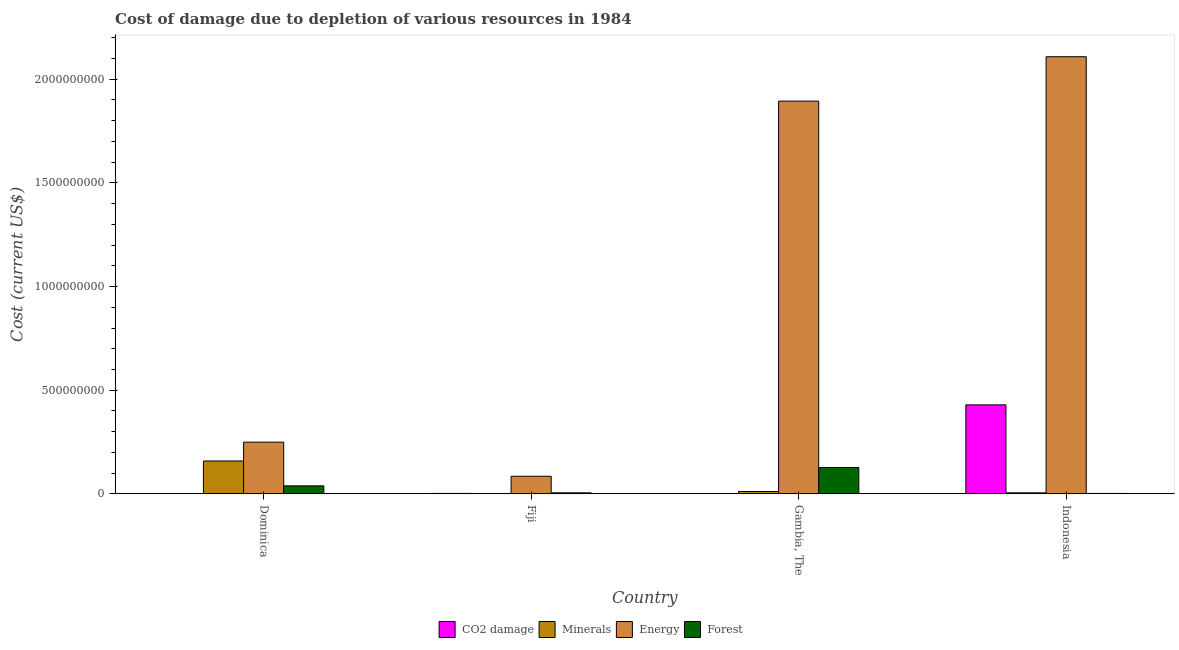How many groups of bars are there?
Your answer should be compact. 4. Are the number of bars per tick equal to the number of legend labels?
Provide a short and direct response. Yes. Are the number of bars on each tick of the X-axis equal?
Provide a short and direct response. Yes. How many bars are there on the 1st tick from the right?
Offer a terse response. 4. What is the cost of damage due to depletion of minerals in Fiji?
Your answer should be very brief. 1.35e+06. Across all countries, what is the maximum cost of damage due to depletion of coal?
Your answer should be very brief. 4.29e+08. Across all countries, what is the minimum cost of damage due to depletion of coal?
Ensure brevity in your answer.  1.68e+05. In which country was the cost of damage due to depletion of forests maximum?
Ensure brevity in your answer.  Gambia, The. In which country was the cost of damage due to depletion of coal minimum?
Offer a very short reply. Dominica. What is the total cost of damage due to depletion of minerals in the graph?
Offer a terse response. 1.76e+08. What is the difference between the cost of damage due to depletion of forests in Dominica and that in Indonesia?
Make the answer very short. 3.66e+07. What is the difference between the cost of damage due to depletion of forests in Fiji and the cost of damage due to depletion of energy in Indonesia?
Your response must be concise. -2.10e+09. What is the average cost of damage due to depletion of coal per country?
Give a very brief answer. 1.08e+08. What is the difference between the cost of damage due to depletion of forests and cost of damage due to depletion of energy in Gambia, The?
Your answer should be very brief. -1.77e+09. In how many countries, is the cost of damage due to depletion of minerals greater than 200000000 US$?
Keep it short and to the point. 0. What is the ratio of the cost of damage due to depletion of energy in Dominica to that in Fiji?
Ensure brevity in your answer.  2.94. What is the difference between the highest and the second highest cost of damage due to depletion of energy?
Your response must be concise. 2.14e+08. What is the difference between the highest and the lowest cost of damage due to depletion of minerals?
Ensure brevity in your answer.  1.57e+08. What does the 2nd bar from the left in Indonesia represents?
Your answer should be compact. Minerals. What does the 4th bar from the right in Fiji represents?
Keep it short and to the point. CO2 damage. How many bars are there?
Keep it short and to the point. 16. Are all the bars in the graph horizontal?
Offer a very short reply. No. Does the graph contain any zero values?
Offer a very short reply. No. Where does the legend appear in the graph?
Offer a terse response. Bottom center. How are the legend labels stacked?
Offer a very short reply. Horizontal. What is the title of the graph?
Your response must be concise. Cost of damage due to depletion of various resources in 1984 . Does "Taxes on exports" appear as one of the legend labels in the graph?
Give a very brief answer. No. What is the label or title of the X-axis?
Offer a very short reply. Country. What is the label or title of the Y-axis?
Ensure brevity in your answer.  Cost (current US$). What is the Cost (current US$) of CO2 damage in Dominica?
Keep it short and to the point. 1.68e+05. What is the Cost (current US$) in Minerals in Dominica?
Ensure brevity in your answer.  1.59e+08. What is the Cost (current US$) in Energy in Dominica?
Keep it short and to the point. 2.49e+08. What is the Cost (current US$) of Forest in Dominica?
Make the answer very short. 3.86e+07. What is the Cost (current US$) of CO2 damage in Fiji?
Provide a succinct answer. 2.23e+06. What is the Cost (current US$) of Minerals in Fiji?
Offer a very short reply. 1.35e+06. What is the Cost (current US$) of Energy in Fiji?
Your response must be concise. 8.49e+07. What is the Cost (current US$) in Forest in Fiji?
Your answer should be very brief. 4.96e+06. What is the Cost (current US$) of CO2 damage in Gambia, The?
Offer a terse response. 6.60e+05. What is the Cost (current US$) in Minerals in Gambia, The?
Ensure brevity in your answer.  1.14e+07. What is the Cost (current US$) in Energy in Gambia, The?
Offer a very short reply. 1.89e+09. What is the Cost (current US$) in Forest in Gambia, The?
Offer a very short reply. 1.27e+08. What is the Cost (current US$) of CO2 damage in Indonesia?
Your answer should be very brief. 4.29e+08. What is the Cost (current US$) of Minerals in Indonesia?
Offer a very short reply. 4.91e+06. What is the Cost (current US$) in Energy in Indonesia?
Provide a short and direct response. 2.11e+09. What is the Cost (current US$) of Forest in Indonesia?
Give a very brief answer. 2.04e+06. Across all countries, what is the maximum Cost (current US$) of CO2 damage?
Your response must be concise. 4.29e+08. Across all countries, what is the maximum Cost (current US$) in Minerals?
Make the answer very short. 1.59e+08. Across all countries, what is the maximum Cost (current US$) of Energy?
Your answer should be very brief. 2.11e+09. Across all countries, what is the maximum Cost (current US$) of Forest?
Ensure brevity in your answer.  1.27e+08. Across all countries, what is the minimum Cost (current US$) of CO2 damage?
Your response must be concise. 1.68e+05. Across all countries, what is the minimum Cost (current US$) of Minerals?
Provide a short and direct response. 1.35e+06. Across all countries, what is the minimum Cost (current US$) of Energy?
Offer a very short reply. 8.49e+07. Across all countries, what is the minimum Cost (current US$) of Forest?
Your answer should be compact. 2.04e+06. What is the total Cost (current US$) of CO2 damage in the graph?
Your answer should be very brief. 4.32e+08. What is the total Cost (current US$) in Minerals in the graph?
Your answer should be very brief. 1.76e+08. What is the total Cost (current US$) in Energy in the graph?
Make the answer very short. 4.34e+09. What is the total Cost (current US$) of Forest in the graph?
Give a very brief answer. 1.73e+08. What is the difference between the Cost (current US$) of CO2 damage in Dominica and that in Fiji?
Offer a very short reply. -2.06e+06. What is the difference between the Cost (current US$) in Minerals in Dominica and that in Fiji?
Make the answer very short. 1.57e+08. What is the difference between the Cost (current US$) of Energy in Dominica and that in Fiji?
Your response must be concise. 1.64e+08. What is the difference between the Cost (current US$) of Forest in Dominica and that in Fiji?
Give a very brief answer. 3.36e+07. What is the difference between the Cost (current US$) of CO2 damage in Dominica and that in Gambia, The?
Your response must be concise. -4.91e+05. What is the difference between the Cost (current US$) in Minerals in Dominica and that in Gambia, The?
Provide a short and direct response. 1.47e+08. What is the difference between the Cost (current US$) in Energy in Dominica and that in Gambia, The?
Make the answer very short. -1.64e+09. What is the difference between the Cost (current US$) of Forest in Dominica and that in Gambia, The?
Give a very brief answer. -8.85e+07. What is the difference between the Cost (current US$) in CO2 damage in Dominica and that in Indonesia?
Provide a succinct answer. -4.29e+08. What is the difference between the Cost (current US$) of Minerals in Dominica and that in Indonesia?
Your response must be concise. 1.54e+08. What is the difference between the Cost (current US$) in Energy in Dominica and that in Indonesia?
Ensure brevity in your answer.  -1.86e+09. What is the difference between the Cost (current US$) in Forest in Dominica and that in Indonesia?
Offer a very short reply. 3.66e+07. What is the difference between the Cost (current US$) of CO2 damage in Fiji and that in Gambia, The?
Give a very brief answer. 1.57e+06. What is the difference between the Cost (current US$) in Minerals in Fiji and that in Gambia, The?
Keep it short and to the point. -1.00e+07. What is the difference between the Cost (current US$) in Energy in Fiji and that in Gambia, The?
Offer a very short reply. -1.81e+09. What is the difference between the Cost (current US$) of Forest in Fiji and that in Gambia, The?
Offer a terse response. -1.22e+08. What is the difference between the Cost (current US$) in CO2 damage in Fiji and that in Indonesia?
Your response must be concise. -4.27e+08. What is the difference between the Cost (current US$) of Minerals in Fiji and that in Indonesia?
Your answer should be compact. -3.56e+06. What is the difference between the Cost (current US$) of Energy in Fiji and that in Indonesia?
Your answer should be compact. -2.02e+09. What is the difference between the Cost (current US$) of Forest in Fiji and that in Indonesia?
Offer a very short reply. 2.92e+06. What is the difference between the Cost (current US$) in CO2 damage in Gambia, The and that in Indonesia?
Ensure brevity in your answer.  -4.29e+08. What is the difference between the Cost (current US$) in Minerals in Gambia, The and that in Indonesia?
Ensure brevity in your answer.  6.45e+06. What is the difference between the Cost (current US$) in Energy in Gambia, The and that in Indonesia?
Offer a very short reply. -2.14e+08. What is the difference between the Cost (current US$) of Forest in Gambia, The and that in Indonesia?
Give a very brief answer. 1.25e+08. What is the difference between the Cost (current US$) in CO2 damage in Dominica and the Cost (current US$) in Minerals in Fiji?
Your answer should be very brief. -1.18e+06. What is the difference between the Cost (current US$) in CO2 damage in Dominica and the Cost (current US$) in Energy in Fiji?
Provide a succinct answer. -8.48e+07. What is the difference between the Cost (current US$) in CO2 damage in Dominica and the Cost (current US$) in Forest in Fiji?
Offer a very short reply. -4.79e+06. What is the difference between the Cost (current US$) of Minerals in Dominica and the Cost (current US$) of Energy in Fiji?
Give a very brief answer. 7.37e+07. What is the difference between the Cost (current US$) of Minerals in Dominica and the Cost (current US$) of Forest in Fiji?
Your answer should be compact. 1.54e+08. What is the difference between the Cost (current US$) in Energy in Dominica and the Cost (current US$) in Forest in Fiji?
Offer a very short reply. 2.44e+08. What is the difference between the Cost (current US$) of CO2 damage in Dominica and the Cost (current US$) of Minerals in Gambia, The?
Your answer should be compact. -1.12e+07. What is the difference between the Cost (current US$) of CO2 damage in Dominica and the Cost (current US$) of Energy in Gambia, The?
Give a very brief answer. -1.89e+09. What is the difference between the Cost (current US$) in CO2 damage in Dominica and the Cost (current US$) in Forest in Gambia, The?
Keep it short and to the point. -1.27e+08. What is the difference between the Cost (current US$) of Minerals in Dominica and the Cost (current US$) of Energy in Gambia, The?
Ensure brevity in your answer.  -1.74e+09. What is the difference between the Cost (current US$) in Minerals in Dominica and the Cost (current US$) in Forest in Gambia, The?
Provide a succinct answer. 3.15e+07. What is the difference between the Cost (current US$) in Energy in Dominica and the Cost (current US$) in Forest in Gambia, The?
Provide a short and direct response. 1.22e+08. What is the difference between the Cost (current US$) in CO2 damage in Dominica and the Cost (current US$) in Minerals in Indonesia?
Ensure brevity in your answer.  -4.74e+06. What is the difference between the Cost (current US$) of CO2 damage in Dominica and the Cost (current US$) of Energy in Indonesia?
Your answer should be compact. -2.11e+09. What is the difference between the Cost (current US$) of CO2 damage in Dominica and the Cost (current US$) of Forest in Indonesia?
Your answer should be very brief. -1.87e+06. What is the difference between the Cost (current US$) of Minerals in Dominica and the Cost (current US$) of Energy in Indonesia?
Your answer should be very brief. -1.95e+09. What is the difference between the Cost (current US$) of Minerals in Dominica and the Cost (current US$) of Forest in Indonesia?
Give a very brief answer. 1.57e+08. What is the difference between the Cost (current US$) of Energy in Dominica and the Cost (current US$) of Forest in Indonesia?
Your response must be concise. 2.47e+08. What is the difference between the Cost (current US$) in CO2 damage in Fiji and the Cost (current US$) in Minerals in Gambia, The?
Give a very brief answer. -9.14e+06. What is the difference between the Cost (current US$) in CO2 damage in Fiji and the Cost (current US$) in Energy in Gambia, The?
Your answer should be compact. -1.89e+09. What is the difference between the Cost (current US$) in CO2 damage in Fiji and the Cost (current US$) in Forest in Gambia, The?
Provide a short and direct response. -1.25e+08. What is the difference between the Cost (current US$) in Minerals in Fiji and the Cost (current US$) in Energy in Gambia, The?
Keep it short and to the point. -1.89e+09. What is the difference between the Cost (current US$) of Minerals in Fiji and the Cost (current US$) of Forest in Gambia, The?
Make the answer very short. -1.26e+08. What is the difference between the Cost (current US$) in Energy in Fiji and the Cost (current US$) in Forest in Gambia, The?
Give a very brief answer. -4.22e+07. What is the difference between the Cost (current US$) in CO2 damage in Fiji and the Cost (current US$) in Minerals in Indonesia?
Your answer should be compact. -2.68e+06. What is the difference between the Cost (current US$) of CO2 damage in Fiji and the Cost (current US$) of Energy in Indonesia?
Your answer should be very brief. -2.11e+09. What is the difference between the Cost (current US$) in CO2 damage in Fiji and the Cost (current US$) in Forest in Indonesia?
Make the answer very short. 1.93e+05. What is the difference between the Cost (current US$) in Minerals in Fiji and the Cost (current US$) in Energy in Indonesia?
Your response must be concise. -2.11e+09. What is the difference between the Cost (current US$) of Minerals in Fiji and the Cost (current US$) of Forest in Indonesia?
Your answer should be very brief. -6.85e+05. What is the difference between the Cost (current US$) in Energy in Fiji and the Cost (current US$) in Forest in Indonesia?
Offer a very short reply. 8.29e+07. What is the difference between the Cost (current US$) in CO2 damage in Gambia, The and the Cost (current US$) in Minerals in Indonesia?
Give a very brief answer. -4.25e+06. What is the difference between the Cost (current US$) in CO2 damage in Gambia, The and the Cost (current US$) in Energy in Indonesia?
Make the answer very short. -2.11e+09. What is the difference between the Cost (current US$) of CO2 damage in Gambia, The and the Cost (current US$) of Forest in Indonesia?
Your answer should be compact. -1.38e+06. What is the difference between the Cost (current US$) in Minerals in Gambia, The and the Cost (current US$) in Energy in Indonesia?
Offer a very short reply. -2.10e+09. What is the difference between the Cost (current US$) of Minerals in Gambia, The and the Cost (current US$) of Forest in Indonesia?
Provide a succinct answer. 9.33e+06. What is the difference between the Cost (current US$) in Energy in Gambia, The and the Cost (current US$) in Forest in Indonesia?
Your answer should be very brief. 1.89e+09. What is the average Cost (current US$) of CO2 damage per country?
Offer a very short reply. 1.08e+08. What is the average Cost (current US$) in Minerals per country?
Provide a succinct answer. 4.41e+07. What is the average Cost (current US$) in Energy per country?
Give a very brief answer. 1.08e+09. What is the average Cost (current US$) of Forest per country?
Provide a succinct answer. 4.32e+07. What is the difference between the Cost (current US$) in CO2 damage and Cost (current US$) in Minerals in Dominica?
Provide a succinct answer. -1.58e+08. What is the difference between the Cost (current US$) in CO2 damage and Cost (current US$) in Energy in Dominica?
Offer a very short reply. -2.49e+08. What is the difference between the Cost (current US$) in CO2 damage and Cost (current US$) in Forest in Dominica?
Your answer should be very brief. -3.84e+07. What is the difference between the Cost (current US$) in Minerals and Cost (current US$) in Energy in Dominica?
Offer a very short reply. -9.08e+07. What is the difference between the Cost (current US$) of Minerals and Cost (current US$) of Forest in Dominica?
Offer a very short reply. 1.20e+08. What is the difference between the Cost (current US$) of Energy and Cost (current US$) of Forest in Dominica?
Make the answer very short. 2.11e+08. What is the difference between the Cost (current US$) in CO2 damage and Cost (current US$) in Minerals in Fiji?
Provide a short and direct response. 8.78e+05. What is the difference between the Cost (current US$) in CO2 damage and Cost (current US$) in Energy in Fiji?
Your answer should be very brief. -8.27e+07. What is the difference between the Cost (current US$) in CO2 damage and Cost (current US$) in Forest in Fiji?
Your answer should be compact. -2.72e+06. What is the difference between the Cost (current US$) in Minerals and Cost (current US$) in Energy in Fiji?
Offer a terse response. -8.36e+07. What is the difference between the Cost (current US$) in Minerals and Cost (current US$) in Forest in Fiji?
Offer a terse response. -3.60e+06. What is the difference between the Cost (current US$) of Energy and Cost (current US$) of Forest in Fiji?
Keep it short and to the point. 8.00e+07. What is the difference between the Cost (current US$) of CO2 damage and Cost (current US$) of Minerals in Gambia, The?
Ensure brevity in your answer.  -1.07e+07. What is the difference between the Cost (current US$) in CO2 damage and Cost (current US$) in Energy in Gambia, The?
Make the answer very short. -1.89e+09. What is the difference between the Cost (current US$) of CO2 damage and Cost (current US$) of Forest in Gambia, The?
Provide a succinct answer. -1.26e+08. What is the difference between the Cost (current US$) of Minerals and Cost (current US$) of Energy in Gambia, The?
Make the answer very short. -1.88e+09. What is the difference between the Cost (current US$) of Minerals and Cost (current US$) of Forest in Gambia, The?
Your answer should be very brief. -1.16e+08. What is the difference between the Cost (current US$) of Energy and Cost (current US$) of Forest in Gambia, The?
Keep it short and to the point. 1.77e+09. What is the difference between the Cost (current US$) of CO2 damage and Cost (current US$) of Minerals in Indonesia?
Offer a terse response. 4.24e+08. What is the difference between the Cost (current US$) of CO2 damage and Cost (current US$) of Energy in Indonesia?
Provide a succinct answer. -1.68e+09. What is the difference between the Cost (current US$) of CO2 damage and Cost (current US$) of Forest in Indonesia?
Keep it short and to the point. 4.27e+08. What is the difference between the Cost (current US$) in Minerals and Cost (current US$) in Energy in Indonesia?
Your response must be concise. -2.10e+09. What is the difference between the Cost (current US$) of Minerals and Cost (current US$) of Forest in Indonesia?
Offer a very short reply. 2.87e+06. What is the difference between the Cost (current US$) in Energy and Cost (current US$) in Forest in Indonesia?
Your response must be concise. 2.11e+09. What is the ratio of the Cost (current US$) in CO2 damage in Dominica to that in Fiji?
Your answer should be compact. 0.08. What is the ratio of the Cost (current US$) of Minerals in Dominica to that in Fiji?
Your response must be concise. 117.23. What is the ratio of the Cost (current US$) in Energy in Dominica to that in Fiji?
Your answer should be compact. 2.94. What is the ratio of the Cost (current US$) in Forest in Dominica to that in Fiji?
Give a very brief answer. 7.79. What is the ratio of the Cost (current US$) in CO2 damage in Dominica to that in Gambia, The?
Ensure brevity in your answer.  0.26. What is the ratio of the Cost (current US$) in Minerals in Dominica to that in Gambia, The?
Give a very brief answer. 13.96. What is the ratio of the Cost (current US$) in Energy in Dominica to that in Gambia, The?
Make the answer very short. 0.13. What is the ratio of the Cost (current US$) in Forest in Dominica to that in Gambia, The?
Make the answer very short. 0.3. What is the ratio of the Cost (current US$) of CO2 damage in Dominica to that in Indonesia?
Offer a very short reply. 0. What is the ratio of the Cost (current US$) in Minerals in Dominica to that in Indonesia?
Offer a terse response. 32.29. What is the ratio of the Cost (current US$) in Energy in Dominica to that in Indonesia?
Provide a succinct answer. 0.12. What is the ratio of the Cost (current US$) in Forest in Dominica to that in Indonesia?
Give a very brief answer. 18.94. What is the ratio of the Cost (current US$) of CO2 damage in Fiji to that in Gambia, The?
Offer a very short reply. 3.38. What is the ratio of the Cost (current US$) of Minerals in Fiji to that in Gambia, The?
Your response must be concise. 0.12. What is the ratio of the Cost (current US$) in Energy in Fiji to that in Gambia, The?
Give a very brief answer. 0.04. What is the ratio of the Cost (current US$) of Forest in Fiji to that in Gambia, The?
Give a very brief answer. 0.04. What is the ratio of the Cost (current US$) in CO2 damage in Fiji to that in Indonesia?
Your response must be concise. 0.01. What is the ratio of the Cost (current US$) in Minerals in Fiji to that in Indonesia?
Offer a terse response. 0.28. What is the ratio of the Cost (current US$) of Energy in Fiji to that in Indonesia?
Your answer should be compact. 0.04. What is the ratio of the Cost (current US$) in Forest in Fiji to that in Indonesia?
Provide a short and direct response. 2.43. What is the ratio of the Cost (current US$) in CO2 damage in Gambia, The to that in Indonesia?
Your answer should be very brief. 0. What is the ratio of the Cost (current US$) of Minerals in Gambia, The to that in Indonesia?
Give a very brief answer. 2.31. What is the ratio of the Cost (current US$) in Energy in Gambia, The to that in Indonesia?
Your response must be concise. 0.9. What is the ratio of the Cost (current US$) of Forest in Gambia, The to that in Indonesia?
Provide a succinct answer. 62.36. What is the difference between the highest and the second highest Cost (current US$) in CO2 damage?
Your answer should be very brief. 4.27e+08. What is the difference between the highest and the second highest Cost (current US$) in Minerals?
Offer a very short reply. 1.47e+08. What is the difference between the highest and the second highest Cost (current US$) in Energy?
Offer a very short reply. 2.14e+08. What is the difference between the highest and the second highest Cost (current US$) of Forest?
Your response must be concise. 8.85e+07. What is the difference between the highest and the lowest Cost (current US$) of CO2 damage?
Provide a short and direct response. 4.29e+08. What is the difference between the highest and the lowest Cost (current US$) of Minerals?
Your answer should be very brief. 1.57e+08. What is the difference between the highest and the lowest Cost (current US$) of Energy?
Ensure brevity in your answer.  2.02e+09. What is the difference between the highest and the lowest Cost (current US$) in Forest?
Your answer should be very brief. 1.25e+08. 